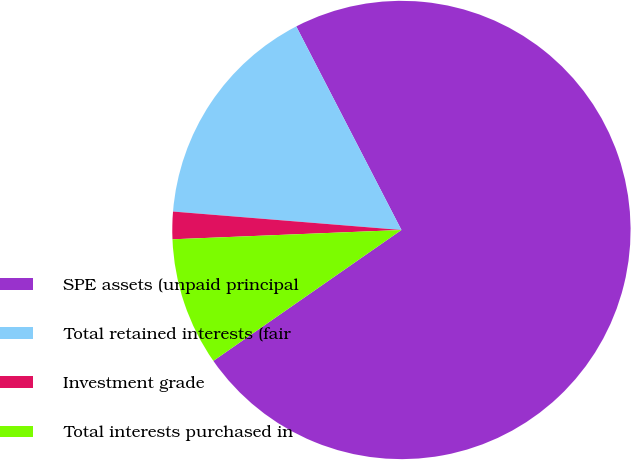Convert chart to OTSL. <chart><loc_0><loc_0><loc_500><loc_500><pie_chart><fcel>SPE assets (unpaid principal<fcel>Total retained interests (fair<fcel>Investment grade<fcel>Total interests purchased in<nl><fcel>72.92%<fcel>16.13%<fcel>1.93%<fcel>9.03%<nl></chart> 